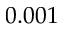Convert formula to latex. <formula><loc_0><loc_0><loc_500><loc_500>0 . 0 0 1</formula> 